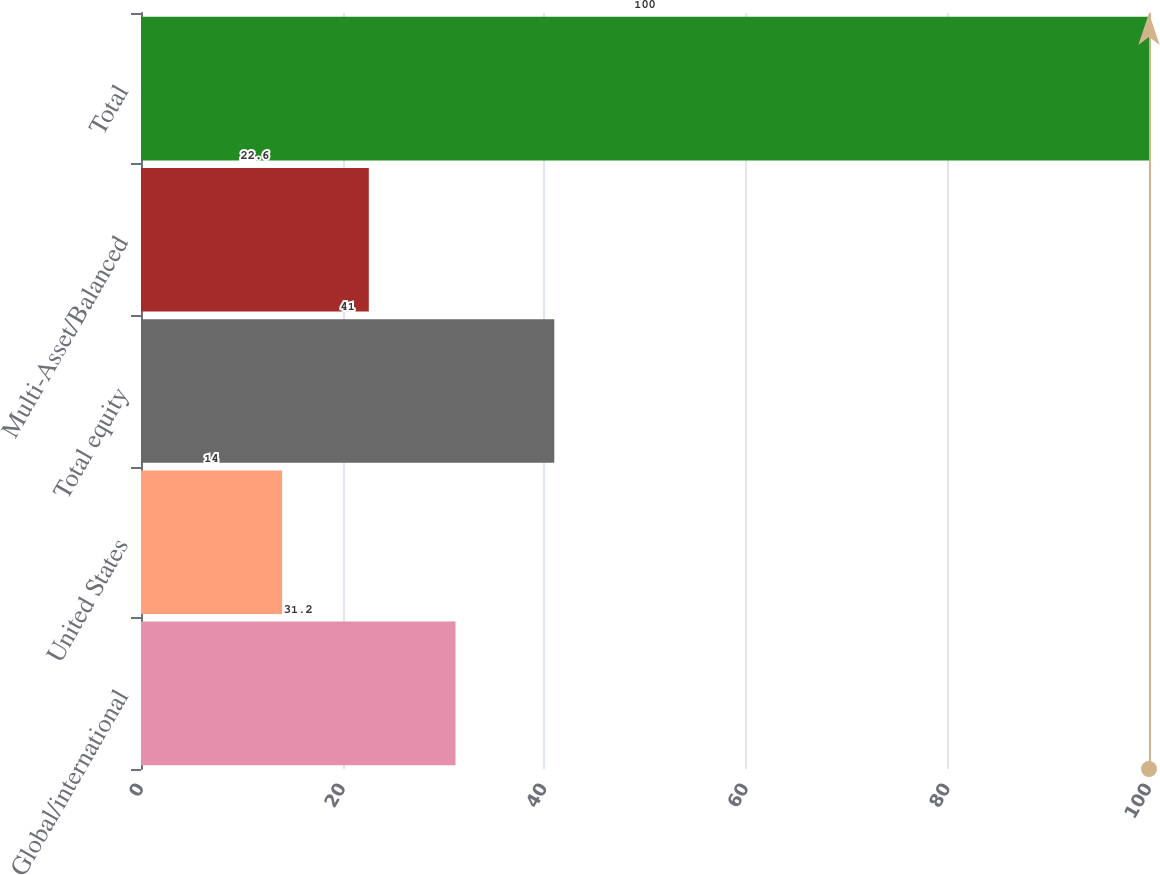Convert chart to OTSL. <chart><loc_0><loc_0><loc_500><loc_500><bar_chart><fcel>Global/international<fcel>United States<fcel>Total equity<fcel>Multi-Asset/Balanced<fcel>Total<nl><fcel>31.2<fcel>14<fcel>41<fcel>22.6<fcel>100<nl></chart> 